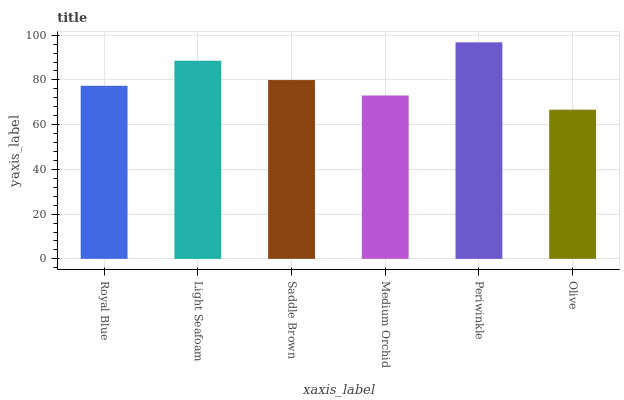Is Light Seafoam the minimum?
Answer yes or no. No. Is Light Seafoam the maximum?
Answer yes or no. No. Is Light Seafoam greater than Royal Blue?
Answer yes or no. Yes. Is Royal Blue less than Light Seafoam?
Answer yes or no. Yes. Is Royal Blue greater than Light Seafoam?
Answer yes or no. No. Is Light Seafoam less than Royal Blue?
Answer yes or no. No. Is Saddle Brown the high median?
Answer yes or no. Yes. Is Royal Blue the low median?
Answer yes or no. Yes. Is Royal Blue the high median?
Answer yes or no. No. Is Periwinkle the low median?
Answer yes or no. No. 